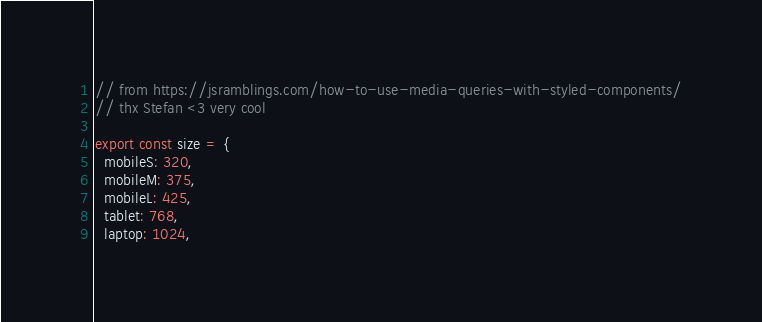Convert code to text. <code><loc_0><loc_0><loc_500><loc_500><_TypeScript_>// from https://jsramblings.com/how-to-use-media-queries-with-styled-components/
// thx Stefan <3 very cool

export const size = {
  mobileS: 320,
  mobileM: 375,
  mobileL: 425,
  tablet: 768,
  laptop: 1024,</code> 